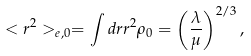Convert formula to latex. <formula><loc_0><loc_0><loc_500><loc_500>< r ^ { 2 } > _ { e , 0 } = \int d r r ^ { 2 } \rho _ { 0 } = \left ( \frac { \lambda } { \mu } \right ) ^ { 2 / 3 } ,</formula> 